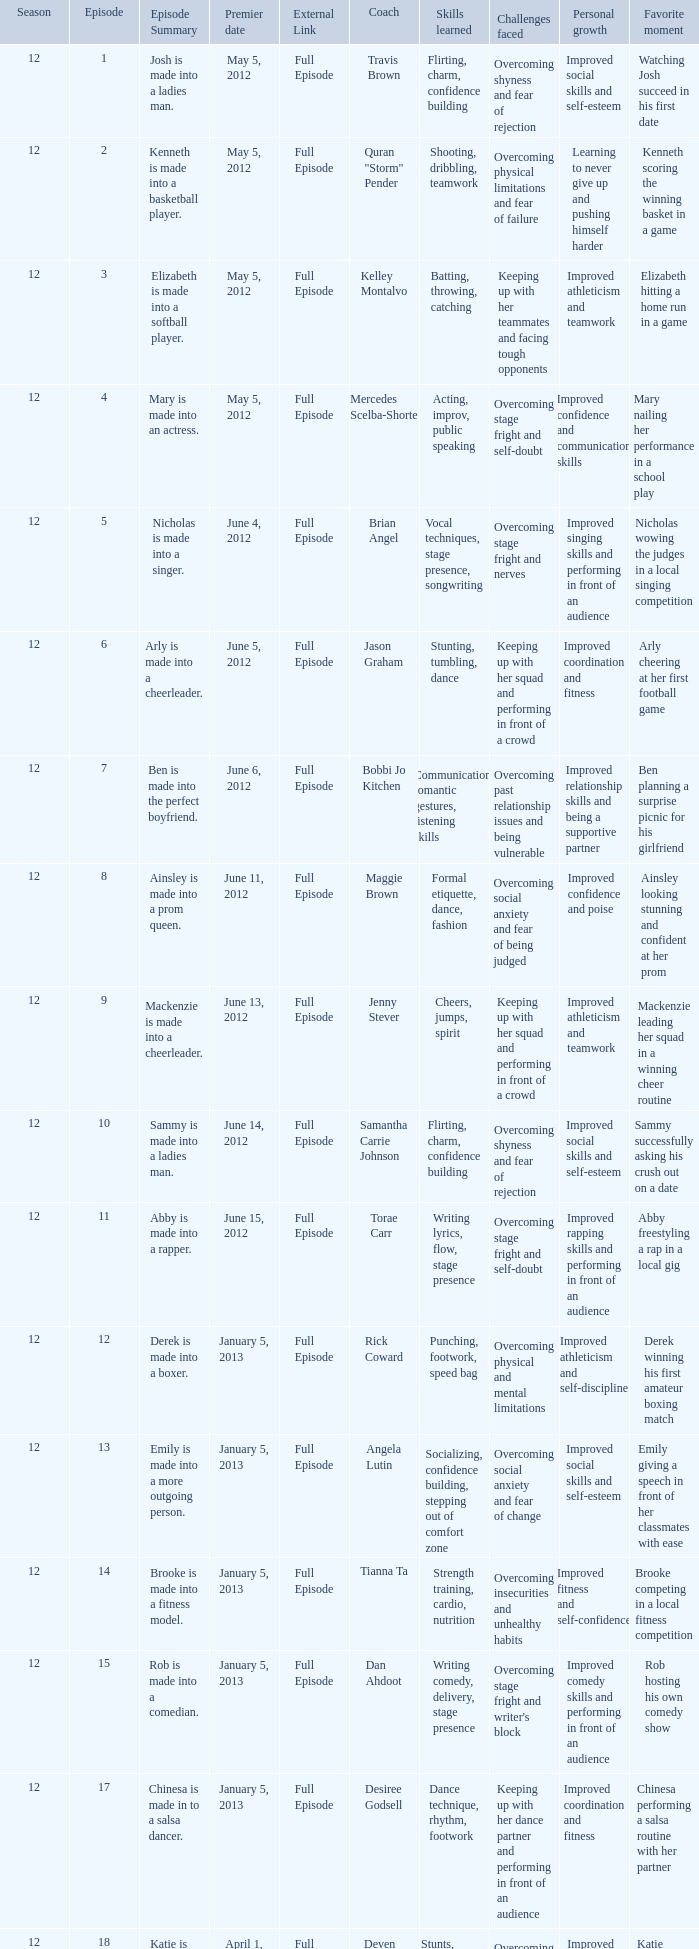Name the episode for travis brown 1.0. 